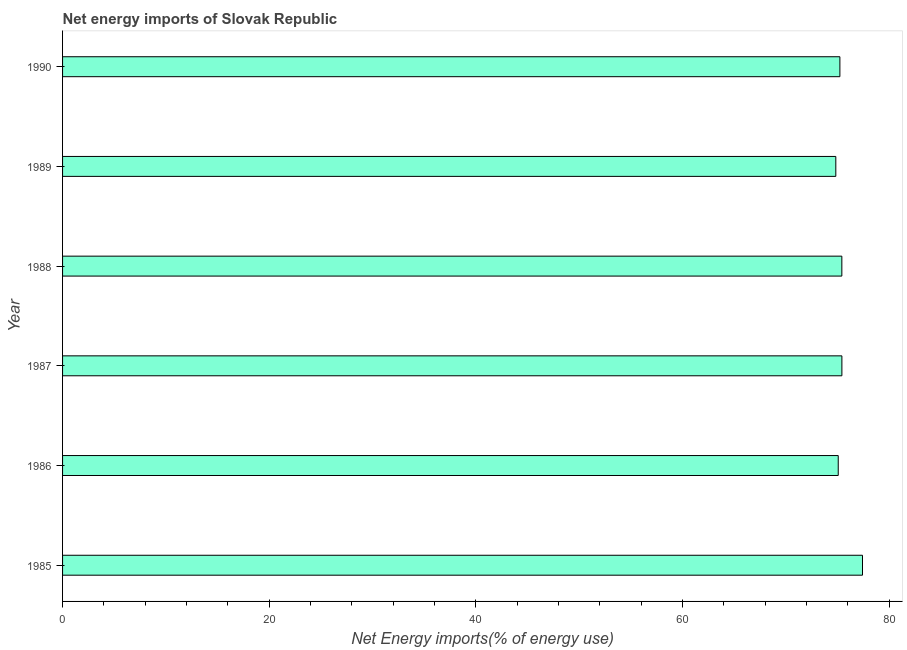Does the graph contain any zero values?
Ensure brevity in your answer.  No. What is the title of the graph?
Offer a very short reply. Net energy imports of Slovak Republic. What is the label or title of the X-axis?
Your response must be concise. Net Energy imports(% of energy use). What is the label or title of the Y-axis?
Ensure brevity in your answer.  Year. What is the energy imports in 1985?
Offer a very short reply. 77.41. Across all years, what is the maximum energy imports?
Your answer should be very brief. 77.41. Across all years, what is the minimum energy imports?
Your answer should be very brief. 74.83. In which year was the energy imports minimum?
Make the answer very short. 1989. What is the sum of the energy imports?
Keep it short and to the point. 453.36. What is the difference between the energy imports in 1987 and 1989?
Offer a very short reply. 0.59. What is the average energy imports per year?
Your response must be concise. 75.56. What is the median energy imports?
Your answer should be compact. 75.32. Do a majority of the years between 1987 and 1985 (inclusive) have energy imports greater than 64 %?
Make the answer very short. Yes. Is the energy imports in 1985 less than that in 1990?
Provide a short and direct response. No. What is the difference between the highest and the second highest energy imports?
Your response must be concise. 1.99. What is the difference between the highest and the lowest energy imports?
Offer a terse response. 2.58. How many bars are there?
Your response must be concise. 6. What is the Net Energy imports(% of energy use) in 1985?
Make the answer very short. 77.41. What is the Net Energy imports(% of energy use) of 1986?
Keep it short and to the point. 75.06. What is the Net Energy imports(% of energy use) of 1987?
Ensure brevity in your answer.  75.42. What is the Net Energy imports(% of energy use) in 1988?
Ensure brevity in your answer.  75.41. What is the Net Energy imports(% of energy use) of 1989?
Your answer should be compact. 74.83. What is the Net Energy imports(% of energy use) in 1990?
Provide a succinct answer. 75.22. What is the difference between the Net Energy imports(% of energy use) in 1985 and 1986?
Offer a terse response. 2.35. What is the difference between the Net Energy imports(% of energy use) in 1985 and 1987?
Make the answer very short. 1.99. What is the difference between the Net Energy imports(% of energy use) in 1985 and 1988?
Offer a very short reply. 2. What is the difference between the Net Energy imports(% of energy use) in 1985 and 1989?
Ensure brevity in your answer.  2.58. What is the difference between the Net Energy imports(% of energy use) in 1985 and 1990?
Your answer should be compact. 2.19. What is the difference between the Net Energy imports(% of energy use) in 1986 and 1987?
Ensure brevity in your answer.  -0.35. What is the difference between the Net Energy imports(% of energy use) in 1986 and 1988?
Your answer should be very brief. -0.35. What is the difference between the Net Energy imports(% of energy use) in 1986 and 1989?
Ensure brevity in your answer.  0.23. What is the difference between the Net Energy imports(% of energy use) in 1986 and 1990?
Offer a terse response. -0.16. What is the difference between the Net Energy imports(% of energy use) in 1987 and 1988?
Offer a terse response. 0.01. What is the difference between the Net Energy imports(% of energy use) in 1987 and 1989?
Your answer should be compact. 0.59. What is the difference between the Net Energy imports(% of energy use) in 1987 and 1990?
Your answer should be very brief. 0.19. What is the difference between the Net Energy imports(% of energy use) in 1988 and 1989?
Your response must be concise. 0.58. What is the difference between the Net Energy imports(% of energy use) in 1988 and 1990?
Provide a short and direct response. 0.19. What is the difference between the Net Energy imports(% of energy use) in 1989 and 1990?
Keep it short and to the point. -0.4. What is the ratio of the Net Energy imports(% of energy use) in 1985 to that in 1986?
Your answer should be very brief. 1.03. What is the ratio of the Net Energy imports(% of energy use) in 1985 to that in 1989?
Your answer should be compact. 1.03. What is the ratio of the Net Energy imports(% of energy use) in 1986 to that in 1987?
Provide a succinct answer. 0.99. What is the ratio of the Net Energy imports(% of energy use) in 1986 to that in 1989?
Give a very brief answer. 1. What is the ratio of the Net Energy imports(% of energy use) in 1987 to that in 1988?
Your answer should be compact. 1. What is the ratio of the Net Energy imports(% of energy use) in 1989 to that in 1990?
Your answer should be compact. 0.99. 